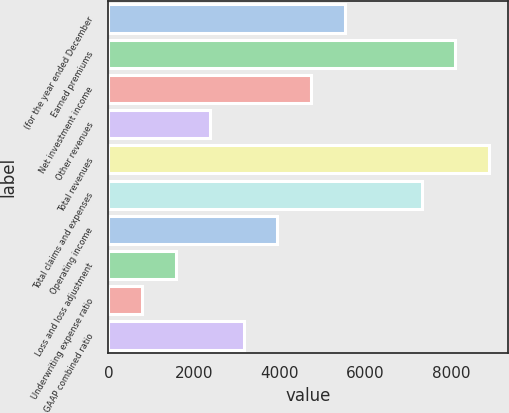Convert chart to OTSL. <chart><loc_0><loc_0><loc_500><loc_500><bar_chart><fcel>(for the year ended December<fcel>Earned premiums<fcel>Net investment income<fcel>Other revenues<fcel>Total revenues<fcel>Total claims and expenses<fcel>Operating income<fcel>Loss and loss adjustment<fcel>Underwriting expense ratio<fcel>GAAP combined ratio<nl><fcel>5522.26<fcel>8102.58<fcel>4733.68<fcel>2367.94<fcel>8891.16<fcel>7314<fcel>3945.1<fcel>1579.36<fcel>790.78<fcel>3156.52<nl></chart> 